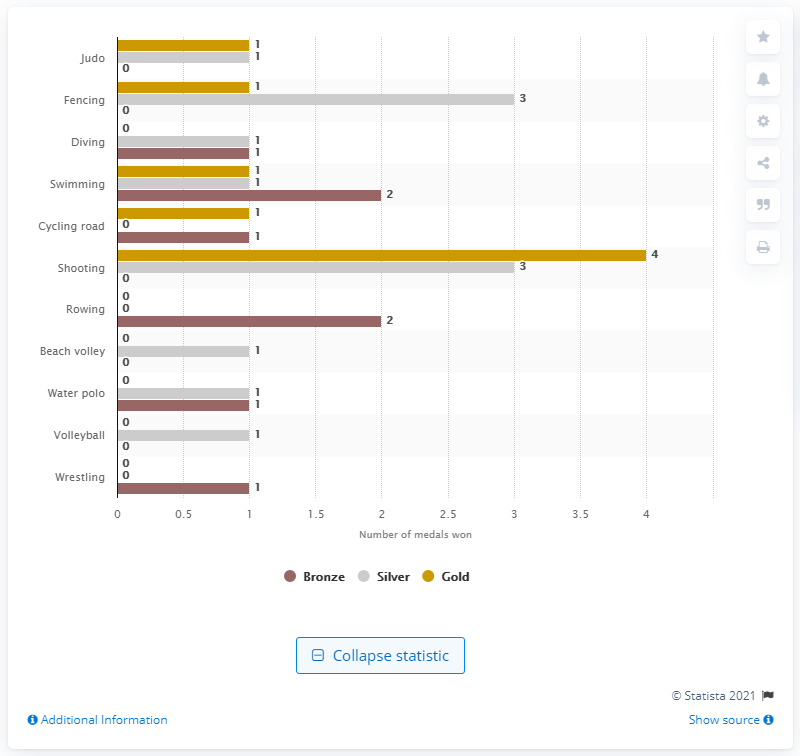Mention a couple of crucial points in this snapshot. The Italian sports team had a particularly successful record in shooting, making it the most successful sport for the team. 